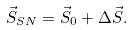<formula> <loc_0><loc_0><loc_500><loc_500>\vec { S } _ { S N } = \vec { S } _ { 0 } + \Delta \vec { S } .</formula> 